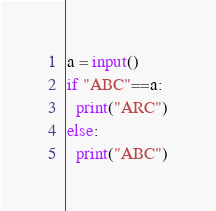Convert code to text. <code><loc_0><loc_0><loc_500><loc_500><_Python_>a = input()
if "ABC"==a:
  print("ARC")
else:
  print("ABC")</code> 